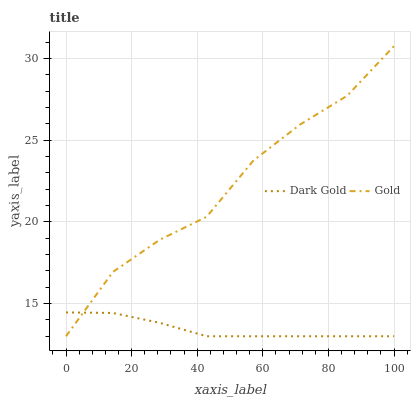Does Dark Gold have the minimum area under the curve?
Answer yes or no. Yes. Does Gold have the maximum area under the curve?
Answer yes or no. Yes. Does Dark Gold have the maximum area under the curve?
Answer yes or no. No. Is Dark Gold the smoothest?
Answer yes or no. Yes. Is Gold the roughest?
Answer yes or no. Yes. Is Dark Gold the roughest?
Answer yes or no. No. Does Gold have the lowest value?
Answer yes or no. Yes. Does Gold have the highest value?
Answer yes or no. Yes. Does Dark Gold have the highest value?
Answer yes or no. No. Does Gold intersect Dark Gold?
Answer yes or no. Yes. Is Gold less than Dark Gold?
Answer yes or no. No. Is Gold greater than Dark Gold?
Answer yes or no. No. 